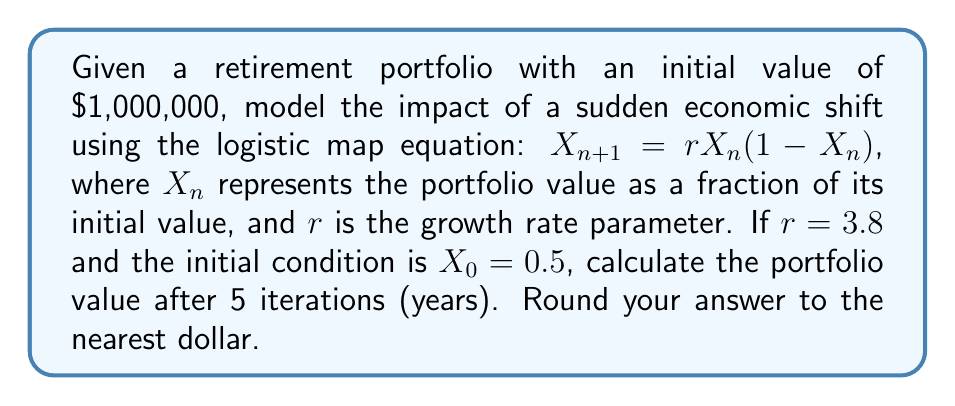Solve this math problem. Let's approach this step-by-step:

1) The logistic map equation is: $X_{n+1} = rX_n(1-X_n)$
   Where $r = 3.8$ and $X_0 = 0.5$

2) Let's calculate each iteration:

   For n = 0:
   $X_1 = 3.8 \cdot 0.5 \cdot (1-0.5) = 3.8 \cdot 0.5 \cdot 0.5 = 0.95$

   For n = 1:
   $X_2 = 3.8 \cdot 0.95 \cdot (1-0.95) = 3.8 \cdot 0.95 \cdot 0.05 = 0.1805$

   For n = 2:
   $X_3 = 3.8 \cdot 0.1805 \cdot (1-0.1805) = 3.8 \cdot 0.1805 \cdot 0.8195 = 0.5623$

   For n = 3:
   $X_4 = 3.8 \cdot 0.5623 \cdot (1-0.5623) = 3.8 \cdot 0.5623 \cdot 0.4377 = 0.9330$

   For n = 4:
   $X_5 = 3.8 \cdot 0.9330 \cdot (1-0.9330) = 3.8 \cdot 0.9330 \cdot 0.0670 = 0.2374$

3) $X_5 = 0.2374$ represents the portfolio value as a fraction of its initial value after 5 iterations.

4) To get the actual portfolio value, multiply by the initial value:
   $0.2374 \cdot \$1,000,000 = \$237,400$

5) Rounding to the nearest dollar: $\$237,400$
Answer: $237,400 